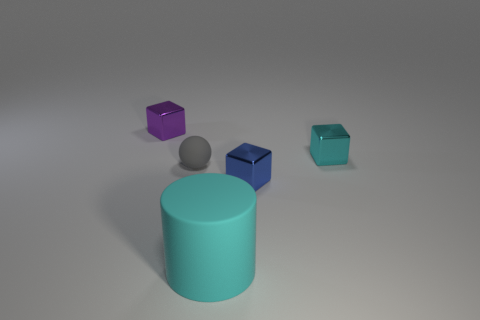Add 2 cyan objects. How many objects exist? 7 Subtract all balls. How many objects are left? 4 Add 2 big objects. How many big objects exist? 3 Subtract 0 yellow cubes. How many objects are left? 5 Subtract all large cyan rubber balls. Subtract all metallic objects. How many objects are left? 2 Add 1 purple shiny objects. How many purple shiny objects are left? 2 